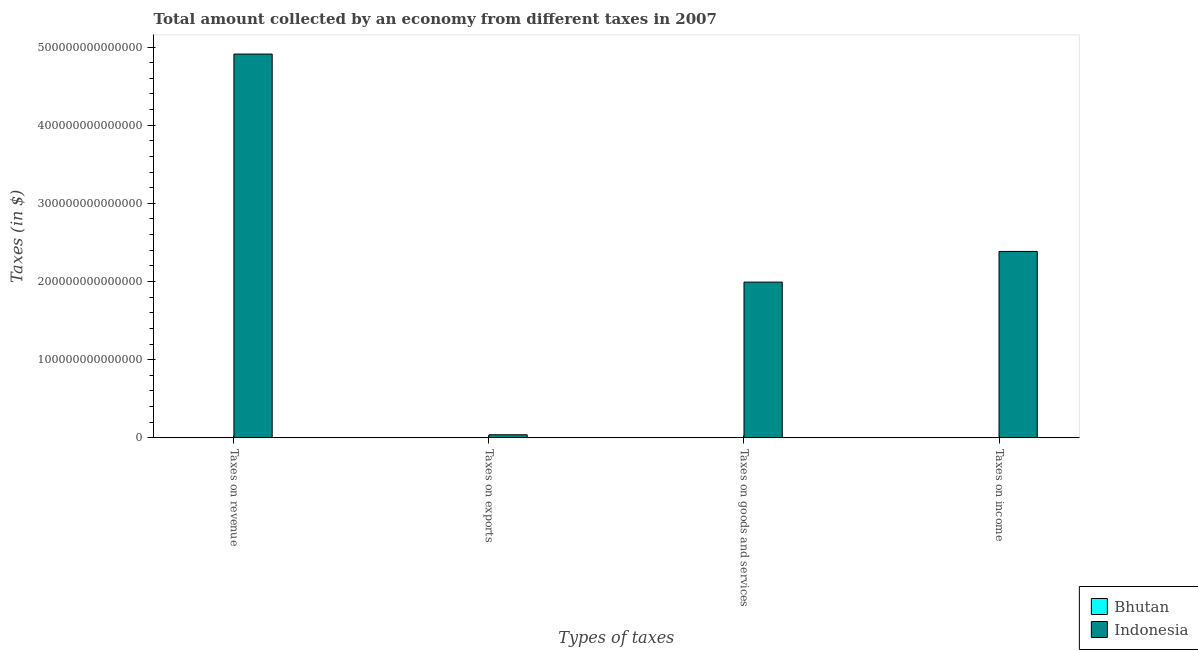How many different coloured bars are there?
Your answer should be compact. 2. How many groups of bars are there?
Offer a very short reply. 4. Are the number of bars on each tick of the X-axis equal?
Your response must be concise. Yes. How many bars are there on the 4th tick from the left?
Provide a succinct answer. 2. How many bars are there on the 4th tick from the right?
Your response must be concise. 2. What is the label of the 1st group of bars from the left?
Offer a very short reply. Taxes on revenue. What is the amount collected as tax on goods in Bhutan?
Provide a short and direct response. 1.42e+09. Across all countries, what is the maximum amount collected as tax on exports?
Provide a short and direct response. 3.96e+12. Across all countries, what is the minimum amount collected as tax on exports?
Make the answer very short. 1.20e+04. In which country was the amount collected as tax on income minimum?
Your answer should be compact. Bhutan. What is the total amount collected as tax on exports in the graph?
Provide a short and direct response. 3.96e+12. What is the difference between the amount collected as tax on revenue in Bhutan and that in Indonesia?
Your response must be concise. -4.91e+14. What is the difference between the amount collected as tax on goods in Bhutan and the amount collected as tax on exports in Indonesia?
Your answer should be compact. -3.96e+12. What is the average amount collected as tax on exports per country?
Provide a short and direct response. 1.98e+12. What is the difference between the amount collected as tax on goods and amount collected as tax on revenue in Bhutan?
Keep it short and to the point. -2.30e+09. What is the ratio of the amount collected as tax on revenue in Bhutan to that in Indonesia?
Offer a terse response. 7.574254748987691e-6. Is the amount collected as tax on goods in Indonesia less than that in Bhutan?
Your answer should be compact. No. Is the difference between the amount collected as tax on income in Bhutan and Indonesia greater than the difference between the amount collected as tax on goods in Bhutan and Indonesia?
Provide a short and direct response. No. What is the difference between the highest and the second highest amount collected as tax on exports?
Provide a short and direct response. 3.96e+12. What is the difference between the highest and the lowest amount collected as tax on income?
Offer a very short reply. 2.39e+14. Is it the case that in every country, the sum of the amount collected as tax on goods and amount collected as tax on income is greater than the sum of amount collected as tax on revenue and amount collected as tax on exports?
Ensure brevity in your answer.  No. What does the 1st bar from the right in Taxes on goods and services represents?
Offer a terse response. Indonesia. Is it the case that in every country, the sum of the amount collected as tax on revenue and amount collected as tax on exports is greater than the amount collected as tax on goods?
Give a very brief answer. Yes. Are all the bars in the graph horizontal?
Offer a terse response. No. How many countries are there in the graph?
Ensure brevity in your answer.  2. What is the difference between two consecutive major ticks on the Y-axis?
Ensure brevity in your answer.  1.00e+14. Does the graph contain any zero values?
Offer a terse response. No. Where does the legend appear in the graph?
Your answer should be compact. Bottom right. What is the title of the graph?
Provide a short and direct response. Total amount collected by an economy from different taxes in 2007. What is the label or title of the X-axis?
Make the answer very short. Types of taxes. What is the label or title of the Y-axis?
Offer a terse response. Taxes (in $). What is the Taxes (in $) of Bhutan in Taxes on revenue?
Provide a short and direct response. 3.72e+09. What is the Taxes (in $) of Indonesia in Taxes on revenue?
Make the answer very short. 4.91e+14. What is the Taxes (in $) of Bhutan in Taxes on exports?
Make the answer very short. 1.20e+04. What is the Taxes (in $) of Indonesia in Taxes on exports?
Your answer should be very brief. 3.96e+12. What is the Taxes (in $) in Bhutan in Taxes on goods and services?
Ensure brevity in your answer.  1.42e+09. What is the Taxes (in $) in Indonesia in Taxes on goods and services?
Keep it short and to the point. 1.99e+14. What is the Taxes (in $) of Bhutan in Taxes on income?
Your response must be concise. 2.11e+09. What is the Taxes (in $) of Indonesia in Taxes on income?
Make the answer very short. 2.39e+14. Across all Types of taxes, what is the maximum Taxes (in $) in Bhutan?
Your answer should be very brief. 3.72e+09. Across all Types of taxes, what is the maximum Taxes (in $) in Indonesia?
Provide a succinct answer. 4.91e+14. Across all Types of taxes, what is the minimum Taxes (in $) of Bhutan?
Offer a terse response. 1.20e+04. Across all Types of taxes, what is the minimum Taxes (in $) in Indonesia?
Offer a very short reply. 3.96e+12. What is the total Taxes (in $) in Bhutan in the graph?
Ensure brevity in your answer.  7.25e+09. What is the total Taxes (in $) in Indonesia in the graph?
Give a very brief answer. 9.33e+14. What is the difference between the Taxes (in $) in Bhutan in Taxes on revenue and that in Taxes on exports?
Offer a very short reply. 3.72e+09. What is the difference between the Taxes (in $) of Indonesia in Taxes on revenue and that in Taxes on exports?
Your answer should be very brief. 4.87e+14. What is the difference between the Taxes (in $) of Bhutan in Taxes on revenue and that in Taxes on goods and services?
Give a very brief answer. 2.30e+09. What is the difference between the Taxes (in $) in Indonesia in Taxes on revenue and that in Taxes on goods and services?
Ensure brevity in your answer.  2.92e+14. What is the difference between the Taxes (in $) in Bhutan in Taxes on revenue and that in Taxes on income?
Offer a very short reply. 1.61e+09. What is the difference between the Taxes (in $) of Indonesia in Taxes on revenue and that in Taxes on income?
Your response must be concise. 2.52e+14. What is the difference between the Taxes (in $) in Bhutan in Taxes on exports and that in Taxes on goods and services?
Ensure brevity in your answer.  -1.42e+09. What is the difference between the Taxes (in $) in Indonesia in Taxes on exports and that in Taxes on goods and services?
Offer a terse response. -1.95e+14. What is the difference between the Taxes (in $) in Bhutan in Taxes on exports and that in Taxes on income?
Your answer should be compact. -2.11e+09. What is the difference between the Taxes (in $) in Indonesia in Taxes on exports and that in Taxes on income?
Keep it short and to the point. -2.35e+14. What is the difference between the Taxes (in $) in Bhutan in Taxes on goods and services and that in Taxes on income?
Give a very brief answer. -6.85e+08. What is the difference between the Taxes (in $) of Indonesia in Taxes on goods and services and that in Taxes on income?
Your answer should be very brief. -3.93e+13. What is the difference between the Taxes (in $) of Bhutan in Taxes on revenue and the Taxes (in $) of Indonesia in Taxes on exports?
Give a very brief answer. -3.96e+12. What is the difference between the Taxes (in $) in Bhutan in Taxes on revenue and the Taxes (in $) in Indonesia in Taxes on goods and services?
Provide a short and direct response. -1.99e+14. What is the difference between the Taxes (in $) in Bhutan in Taxes on revenue and the Taxes (in $) in Indonesia in Taxes on income?
Provide a succinct answer. -2.39e+14. What is the difference between the Taxes (in $) of Bhutan in Taxes on exports and the Taxes (in $) of Indonesia in Taxes on goods and services?
Your response must be concise. -1.99e+14. What is the difference between the Taxes (in $) in Bhutan in Taxes on exports and the Taxes (in $) in Indonesia in Taxes on income?
Your answer should be compact. -2.39e+14. What is the difference between the Taxes (in $) in Bhutan in Taxes on goods and services and the Taxes (in $) in Indonesia in Taxes on income?
Ensure brevity in your answer.  -2.39e+14. What is the average Taxes (in $) of Bhutan per Types of taxes?
Provide a short and direct response. 1.81e+09. What is the average Taxes (in $) in Indonesia per Types of taxes?
Make the answer very short. 2.33e+14. What is the difference between the Taxes (in $) in Bhutan and Taxes (in $) in Indonesia in Taxes on revenue?
Keep it short and to the point. -4.91e+14. What is the difference between the Taxes (in $) of Bhutan and Taxes (in $) of Indonesia in Taxes on exports?
Provide a succinct answer. -3.96e+12. What is the difference between the Taxes (in $) of Bhutan and Taxes (in $) of Indonesia in Taxes on goods and services?
Offer a very short reply. -1.99e+14. What is the difference between the Taxes (in $) in Bhutan and Taxes (in $) in Indonesia in Taxes on income?
Your answer should be very brief. -2.39e+14. What is the ratio of the Taxes (in $) in Bhutan in Taxes on revenue to that in Taxes on exports?
Ensure brevity in your answer.  3.10e+05. What is the ratio of the Taxes (in $) of Indonesia in Taxes on revenue to that in Taxes on exports?
Your answer should be compact. 123.96. What is the ratio of the Taxes (in $) of Bhutan in Taxes on revenue to that in Taxes on goods and services?
Give a very brief answer. 2.61. What is the ratio of the Taxes (in $) of Indonesia in Taxes on revenue to that in Taxes on goods and services?
Your answer should be very brief. 2.46. What is the ratio of the Taxes (in $) in Bhutan in Taxes on revenue to that in Taxes on income?
Provide a succinct answer. 1.76. What is the ratio of the Taxes (in $) of Indonesia in Taxes on revenue to that in Taxes on income?
Offer a very short reply. 2.06. What is the ratio of the Taxes (in $) in Bhutan in Taxes on exports to that in Taxes on goods and services?
Ensure brevity in your answer.  0. What is the ratio of the Taxes (in $) of Indonesia in Taxes on exports to that in Taxes on goods and services?
Give a very brief answer. 0.02. What is the ratio of the Taxes (in $) of Indonesia in Taxes on exports to that in Taxes on income?
Provide a succinct answer. 0.02. What is the ratio of the Taxes (in $) in Bhutan in Taxes on goods and services to that in Taxes on income?
Your answer should be very brief. 0.68. What is the ratio of the Taxes (in $) of Indonesia in Taxes on goods and services to that in Taxes on income?
Keep it short and to the point. 0.84. What is the difference between the highest and the second highest Taxes (in $) of Bhutan?
Provide a short and direct response. 1.61e+09. What is the difference between the highest and the second highest Taxes (in $) in Indonesia?
Keep it short and to the point. 2.52e+14. What is the difference between the highest and the lowest Taxes (in $) of Bhutan?
Provide a short and direct response. 3.72e+09. What is the difference between the highest and the lowest Taxes (in $) of Indonesia?
Ensure brevity in your answer.  4.87e+14. 